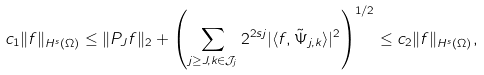Convert formula to latex. <formula><loc_0><loc_0><loc_500><loc_500>c _ { 1 } \| f \| _ { H ^ { s } ( \Omega ) } \leq \| P _ { J } f \| _ { 2 } + \left ( \sum _ { j \geq J , k \in \mathcal { J } _ { j } } 2 ^ { 2 s j } | \langle f , \tilde { \Psi } _ { j , k } \rangle | ^ { 2 } \right ) ^ { 1 / 2 } \leq c _ { 2 } \| f \| _ { H ^ { s } ( \Omega ) } ,</formula> 